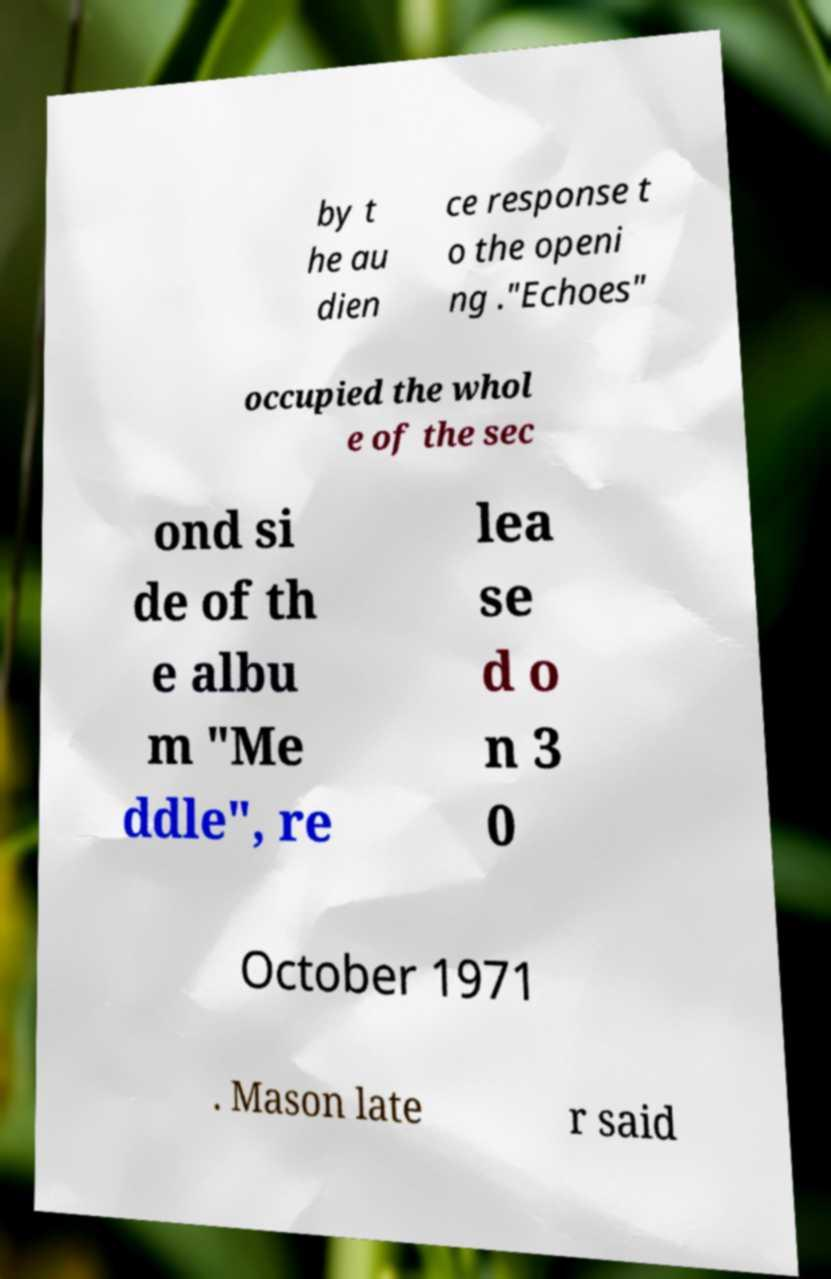Can you read and provide the text displayed in the image?This photo seems to have some interesting text. Can you extract and type it out for me? by t he au dien ce response t o the openi ng ."Echoes" occupied the whol e of the sec ond si de of th e albu m "Me ddle", re lea se d o n 3 0 October 1971 . Mason late r said 